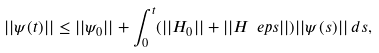<formula> <loc_0><loc_0><loc_500><loc_500>| | \psi ( t ) | | \leq | | \psi _ { 0 } | | + \int _ { 0 } ^ { t } ( | | H _ { 0 } | | + | | H _ { \ } e p s | | ) | | \psi ( s ) | | \, d s ,</formula> 